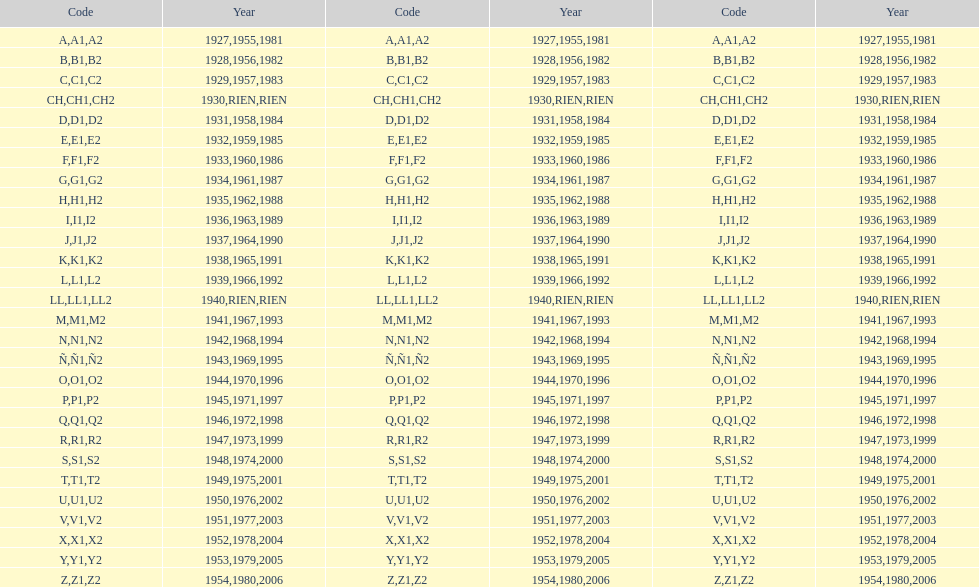Apart from 1927, what year did the code initiate with a? 1955, 1981. 